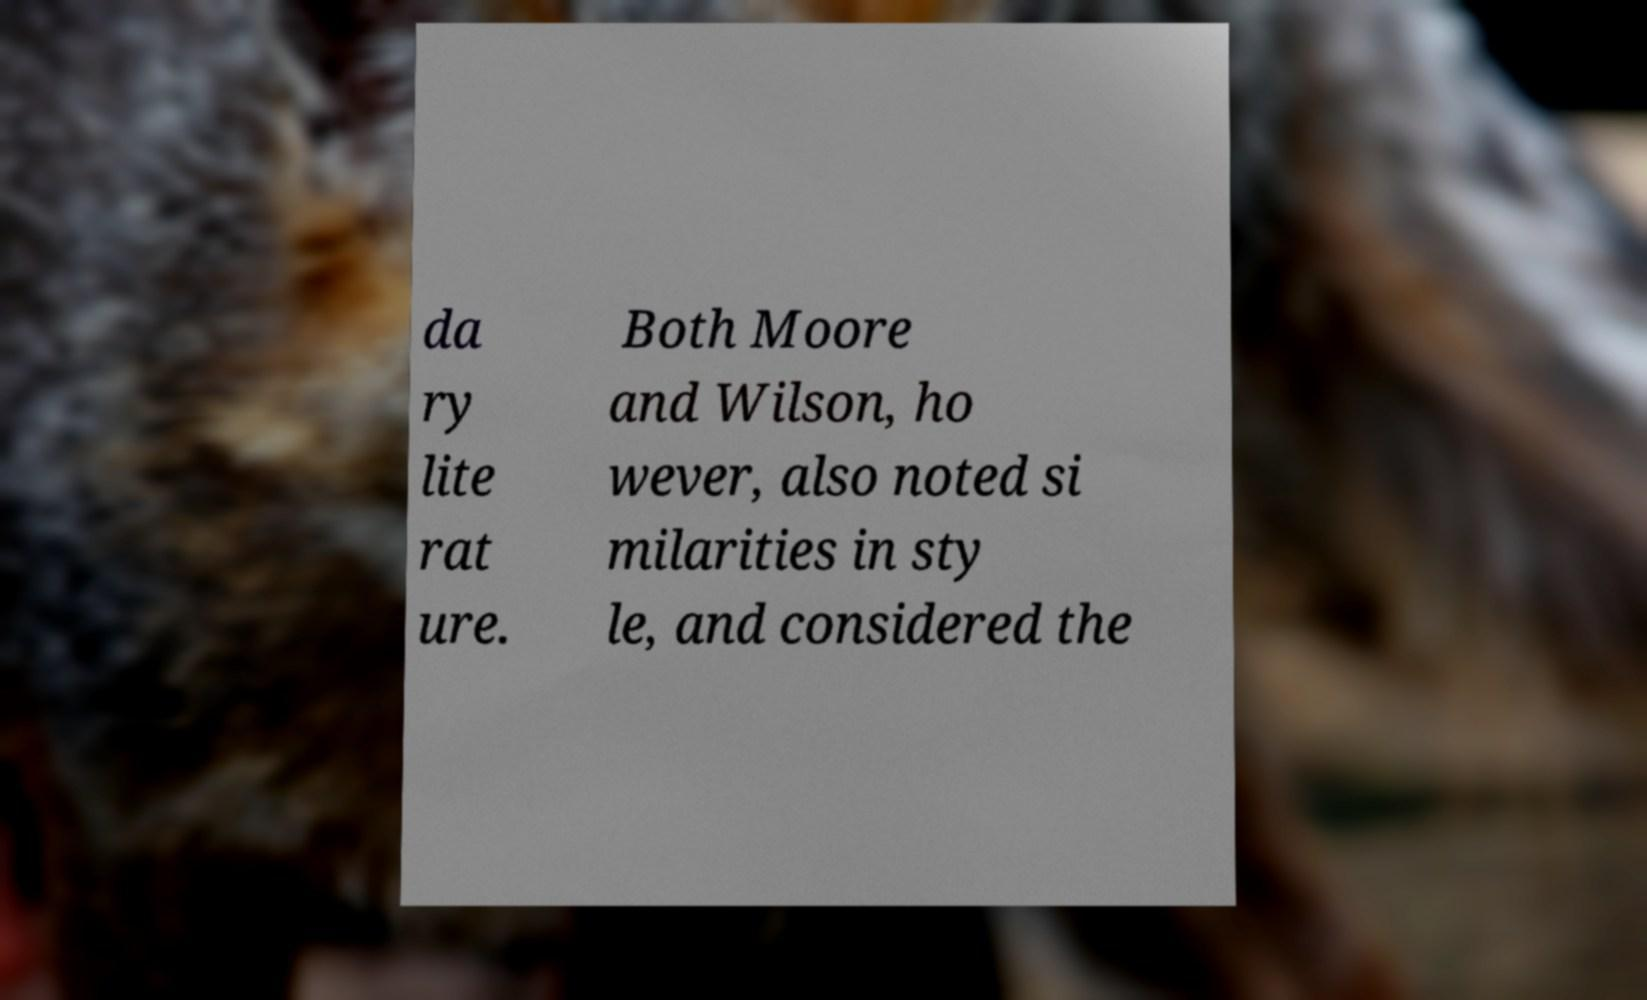Please identify and transcribe the text found in this image. da ry lite rat ure. Both Moore and Wilson, ho wever, also noted si milarities in sty le, and considered the 